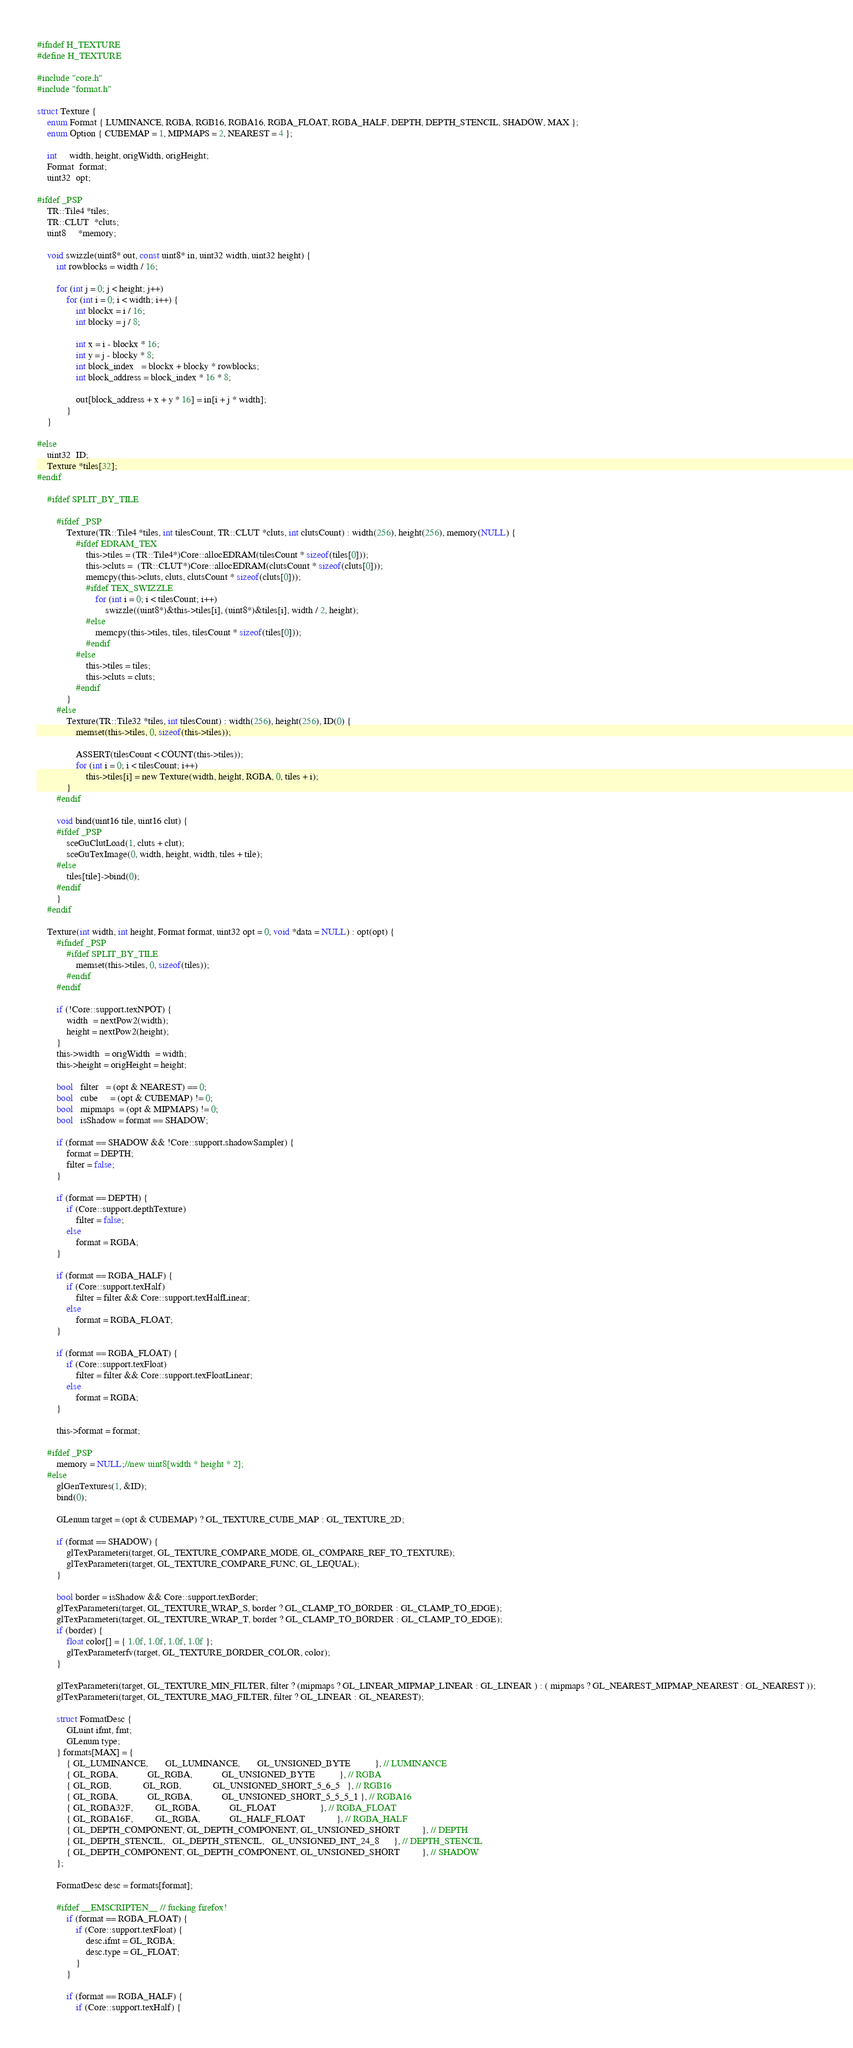<code> <loc_0><loc_0><loc_500><loc_500><_C_>#ifndef H_TEXTURE
#define H_TEXTURE

#include "core.h"
#include "format.h"

struct Texture {
    enum Format { LUMINANCE, RGBA, RGB16, RGBA16, RGBA_FLOAT, RGBA_HALF, DEPTH, DEPTH_STENCIL, SHADOW, MAX };
    enum Option { CUBEMAP = 1, MIPMAPS = 2, NEAREST = 4 };

    int     width, height, origWidth, origHeight;
    Format  format;
    uint32  opt;

#ifdef _PSP
    TR::Tile4 *tiles;
    TR::CLUT  *cluts;
    uint8     *memory;

    void swizzle(uint8* out, const uint8* in, uint32 width, uint32 height) {
        int rowblocks = width / 16;

        for (int j = 0; j < height; j++)
            for (int i = 0; i < width; i++) {
                int blockx = i / 16;
                int blocky = j / 8;

                int x = i - blockx * 16;
                int y = j - blocky * 8;
                int block_index   = blockx + blocky * rowblocks;
                int block_address = block_index * 16 * 8;

                out[block_address + x + y * 16] = in[i + j * width];
            }
    }

#else
    uint32  ID;
    Texture *tiles[32];
#endif

    #ifdef SPLIT_BY_TILE

        #ifdef _PSP
            Texture(TR::Tile4 *tiles, int tilesCount, TR::CLUT *cluts, int clutsCount) : width(256), height(256), memory(NULL) {
                #ifdef EDRAM_TEX
                    this->tiles = (TR::Tile4*)Core::allocEDRAM(tilesCount * sizeof(tiles[0]));
                    this->cluts =  (TR::CLUT*)Core::allocEDRAM(clutsCount * sizeof(cluts[0]));
                    memcpy(this->cluts, cluts, clutsCount * sizeof(cluts[0]));
                    #ifdef TEX_SWIZZLE
                        for (int i = 0; i < tilesCount; i++)
                            swizzle((uint8*)&this->tiles[i], (uint8*)&tiles[i], width / 2, height);
                    #else
                        memcpy(this->tiles, tiles, tilesCount * sizeof(tiles[0]));
                    #endif
                #else
                    this->tiles = tiles;
                    this->cluts = cluts;
                #endif
            }
        #else
            Texture(TR::Tile32 *tiles, int tilesCount) : width(256), height(256), ID(0) {
                memset(this->tiles, 0, sizeof(this->tiles));

                ASSERT(tilesCount < COUNT(this->tiles));
                for (int i = 0; i < tilesCount; i++)
                    this->tiles[i] = new Texture(width, height, RGBA, 0, tiles + i);
            }
        #endif

        void bind(uint16 tile, uint16 clut) {
        #ifdef _PSP
            sceGuClutLoad(1, cluts + clut);
            sceGuTexImage(0, width, height, width, tiles + tile);
        #else
            tiles[tile]->bind(0);
        #endif
        }
    #endif

    Texture(int width, int height, Format format, uint32 opt = 0, void *data = NULL) : opt(opt) {
        #ifndef _PSP
            #ifdef SPLIT_BY_TILE
                memset(this->tiles, 0, sizeof(tiles));
            #endif
        #endif

        if (!Core::support.texNPOT) {
            width  = nextPow2(width);
            height = nextPow2(height);
        }
        this->width  = origWidth  = width;
        this->height = origHeight = height;

        bool   filter   = (opt & NEAREST) == 0;
        bool   cube     = (opt & CUBEMAP) != 0;
        bool   mipmaps  = (opt & MIPMAPS) != 0;
        bool   isShadow = format == SHADOW;

        if (format == SHADOW && !Core::support.shadowSampler) {
            format = DEPTH;
            filter = false;
        }

        if (format == DEPTH) {
            if (Core::support.depthTexture)
                filter = false;
            else
                format = RGBA;
        }

        if (format == RGBA_HALF) {
            if (Core::support.texHalf)
                filter = filter && Core::support.texHalfLinear;
            else
                format = RGBA_FLOAT;
        }

        if (format == RGBA_FLOAT) {
            if (Core::support.texFloat)
                filter = filter && Core::support.texFloatLinear;
            else
                format = RGBA;
        }

        this->format = format;

    #ifdef _PSP
        memory = NULL;//new uint8[width * height * 2];
    #else
        glGenTextures(1, &ID);
        bind(0);

        GLenum target = (opt & CUBEMAP) ? GL_TEXTURE_CUBE_MAP : GL_TEXTURE_2D;

        if (format == SHADOW) {
            glTexParameteri(target, GL_TEXTURE_COMPARE_MODE, GL_COMPARE_REF_TO_TEXTURE);
            glTexParameteri(target, GL_TEXTURE_COMPARE_FUNC, GL_LEQUAL);
        }

        bool border = isShadow && Core::support.texBorder;
        glTexParameteri(target, GL_TEXTURE_WRAP_S, border ? GL_CLAMP_TO_BORDER : GL_CLAMP_TO_EDGE);
        glTexParameteri(target, GL_TEXTURE_WRAP_T, border ? GL_CLAMP_TO_BORDER : GL_CLAMP_TO_EDGE);
        if (border) {
            float color[] = { 1.0f, 1.0f, 1.0f, 1.0f };
            glTexParameterfv(target, GL_TEXTURE_BORDER_COLOR, color);
        }

        glTexParameteri(target, GL_TEXTURE_MIN_FILTER, filter ? (mipmaps ? GL_LINEAR_MIPMAP_LINEAR : GL_LINEAR ) : ( mipmaps ? GL_NEAREST_MIPMAP_NEAREST : GL_NEAREST ));
        glTexParameteri(target, GL_TEXTURE_MAG_FILTER, filter ? GL_LINEAR : GL_NEAREST);

        struct FormatDesc {
            GLuint ifmt, fmt;
            GLenum type;
        } formats[MAX] = {            
            { GL_LUMINANCE,       GL_LUMINANCE,       GL_UNSIGNED_BYTE          }, // LUMINANCE
            { GL_RGBA,            GL_RGBA,            GL_UNSIGNED_BYTE          }, // RGBA
            { GL_RGB,             GL_RGB,             GL_UNSIGNED_SHORT_5_6_5   }, // RGB16
            { GL_RGBA,            GL_RGBA,            GL_UNSIGNED_SHORT_5_5_5_1 }, // RGBA16
            { GL_RGBA32F,         GL_RGBA,            GL_FLOAT                  }, // RGBA_FLOAT
            { GL_RGBA16F,         GL_RGBA,            GL_HALF_FLOAT             }, // RGBA_HALF
            { GL_DEPTH_COMPONENT, GL_DEPTH_COMPONENT, GL_UNSIGNED_SHORT         }, // DEPTH
            { GL_DEPTH_STENCIL,   GL_DEPTH_STENCIL,   GL_UNSIGNED_INT_24_8      }, // DEPTH_STENCIL
            { GL_DEPTH_COMPONENT, GL_DEPTH_COMPONENT, GL_UNSIGNED_SHORT         }, // SHADOW
        };

        FormatDesc desc = formats[format];

        #ifdef __EMSCRIPTEN__ // fucking firefox!
            if (format == RGBA_FLOAT) {
                if (Core::support.texFloat) {
                    desc.ifmt = GL_RGBA;
                    desc.type = GL_FLOAT;
                }
            }

            if (format == RGBA_HALF) {
                if (Core::support.texHalf) {</code> 